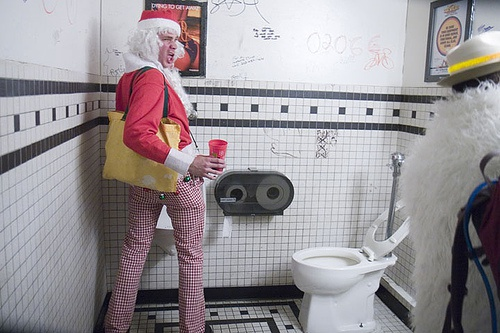Describe the objects in this image and their specific colors. I can see people in lightgray, gray, darkgray, and maroon tones, toilet in lightgray and darkgray tones, handbag in lightgray, olive, and gray tones, backpack in lightgray, black, gray, and navy tones, and cup in lightgray, salmon, and brown tones in this image. 